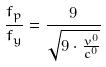<formula> <loc_0><loc_0><loc_500><loc_500>\frac { f _ { p } } { f _ { y } } = \frac { 9 } { \sqrt { 9 \cdot \frac { v ^ { 0 } } { c ^ { 0 } } } }</formula> 